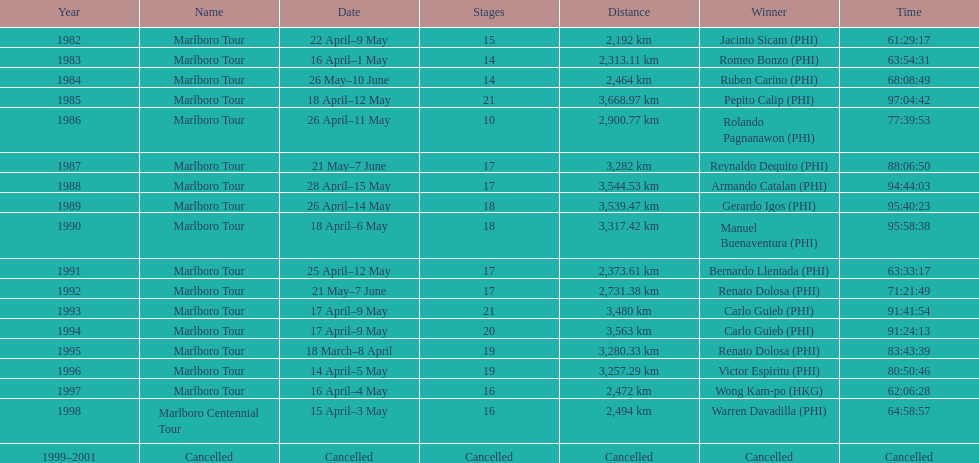Who is mentioned after romeo bonzo? Ruben Carino (PHI). 